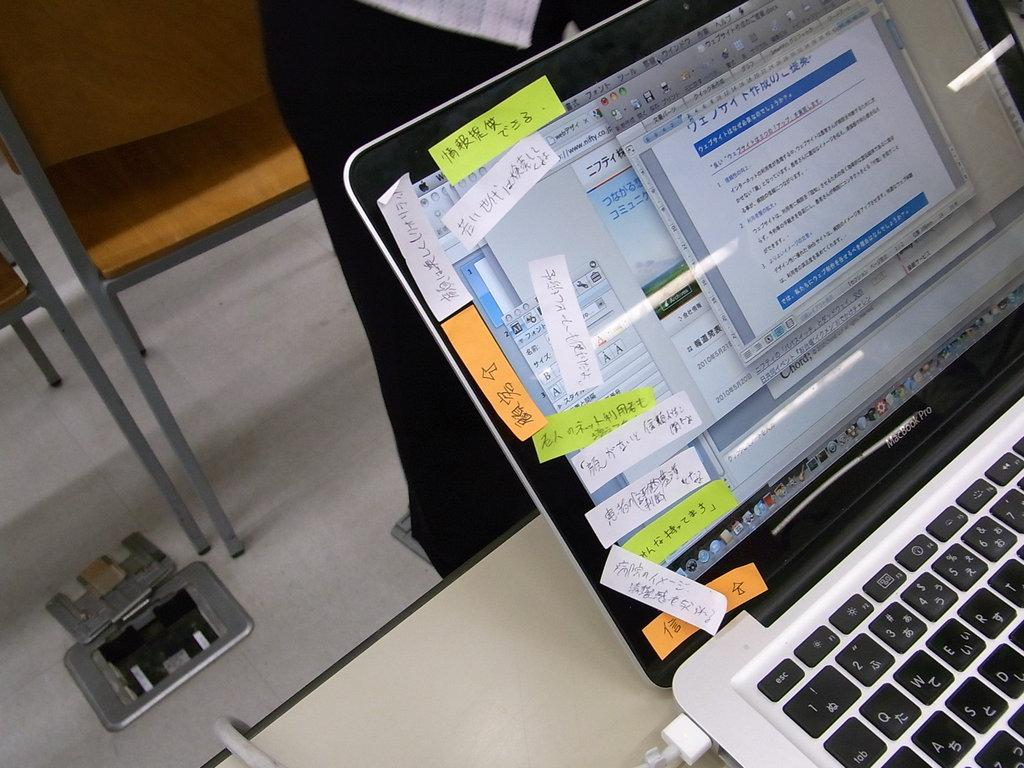<image>
Share a concise interpretation of the image provided. The label on a partially visible laptop computer indicates that it is a MacBook Pro. 